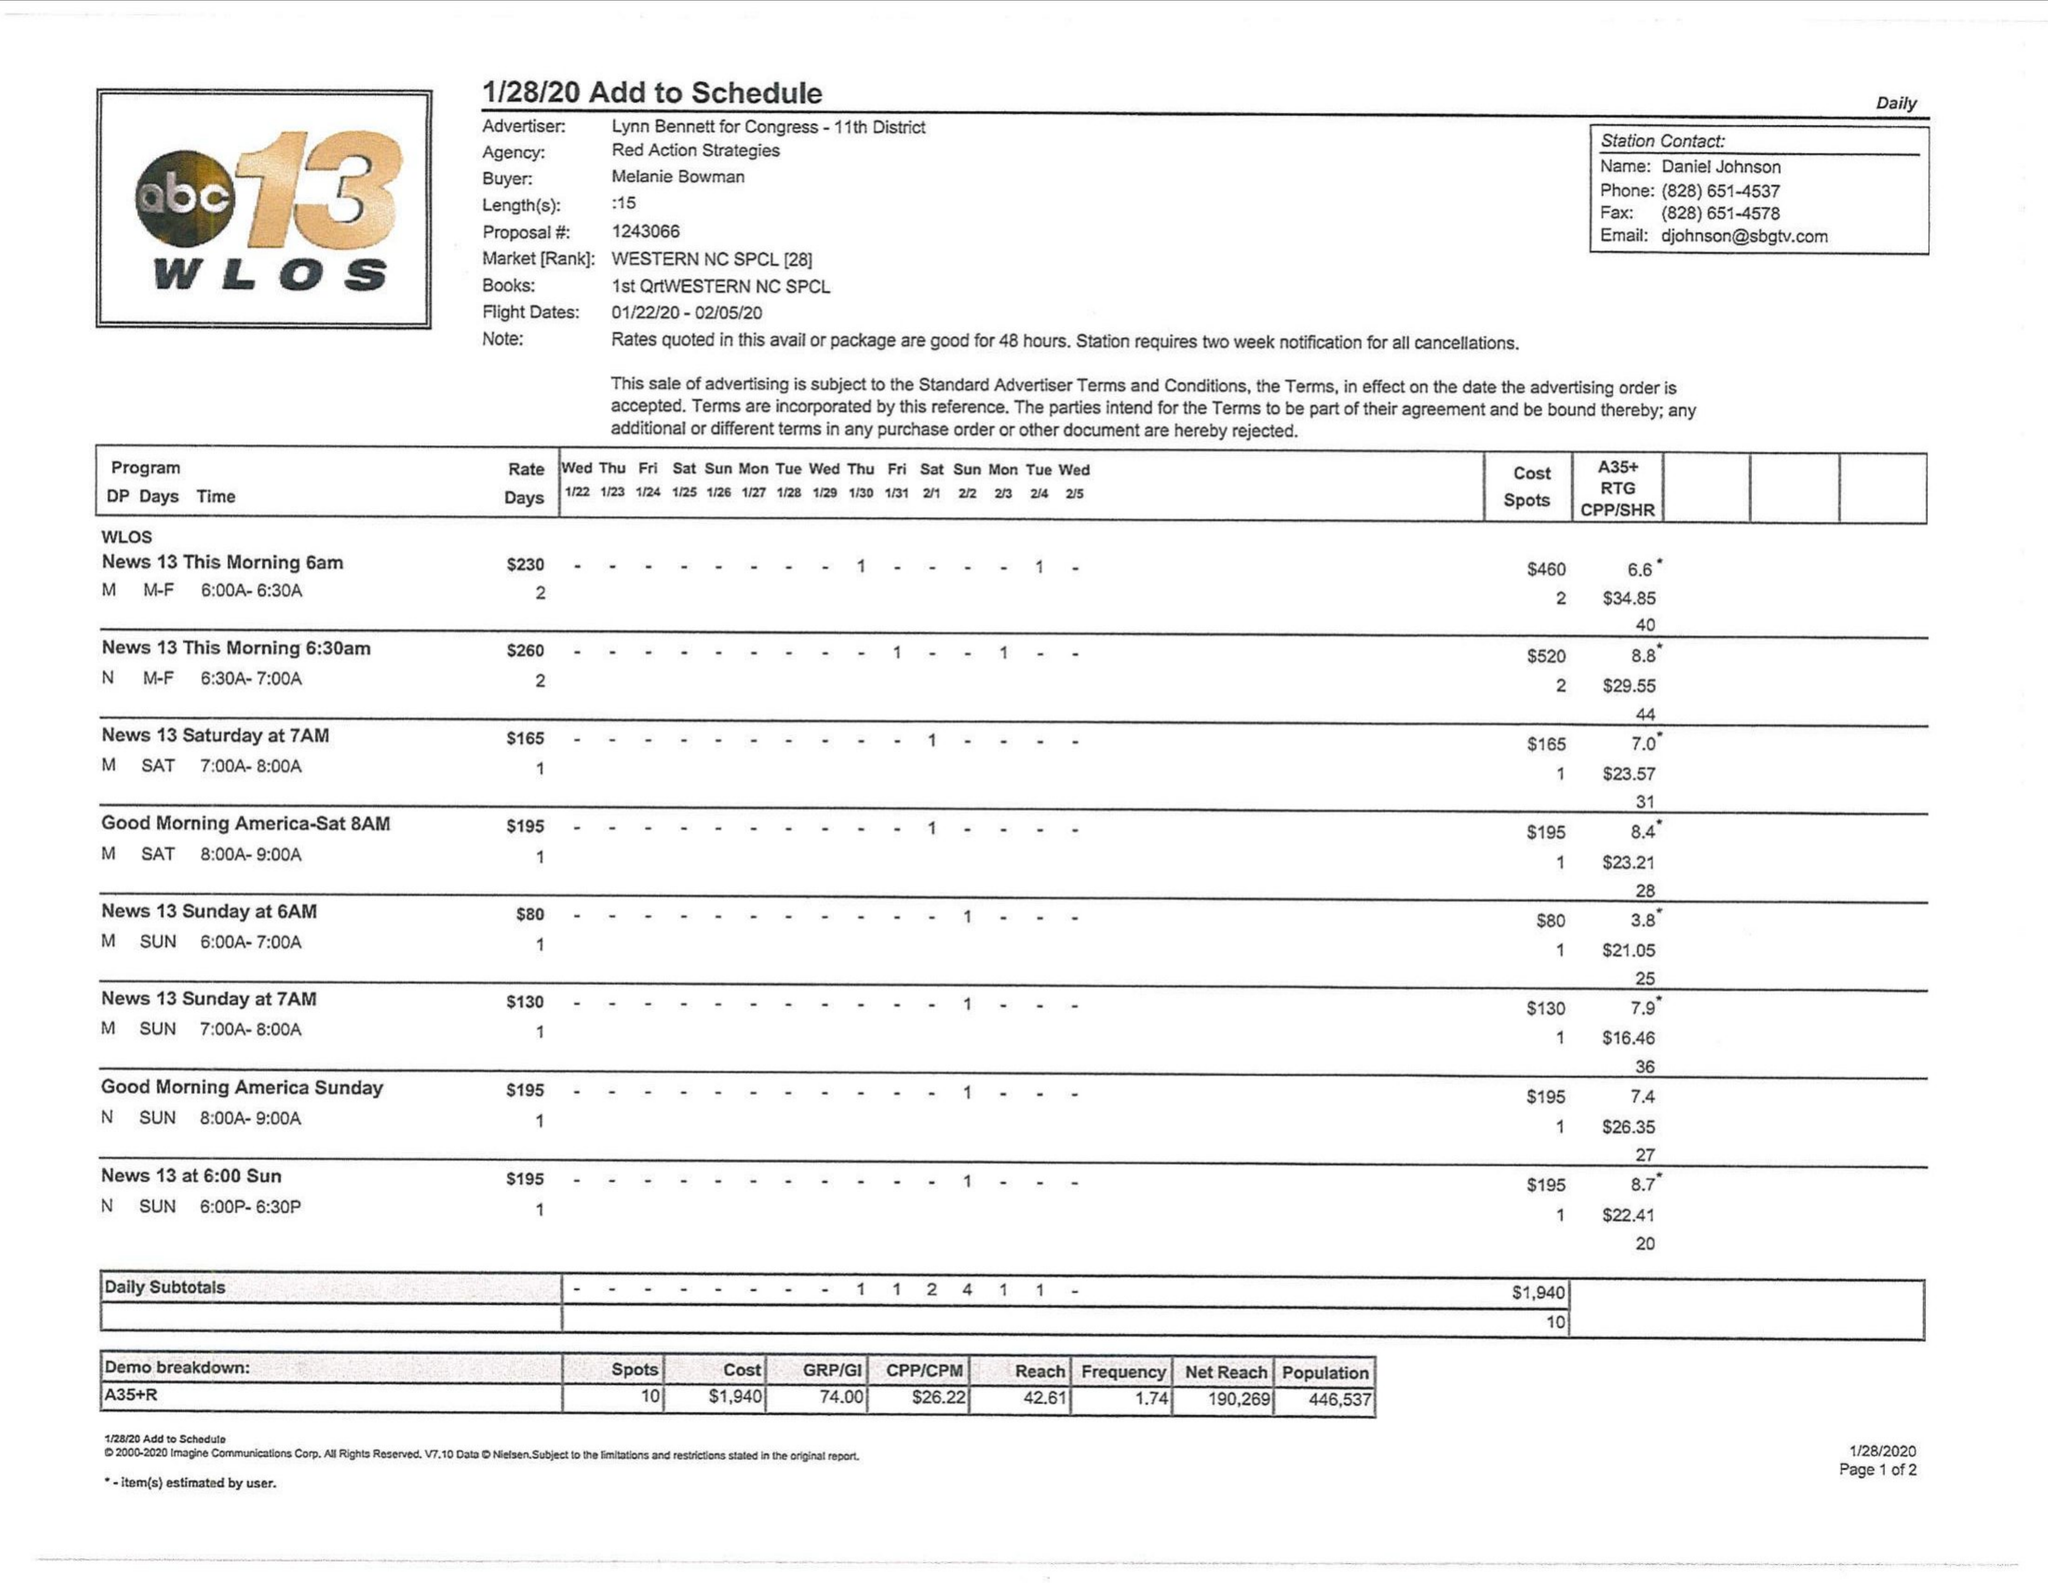What is the value for the advertiser?
Answer the question using a single word or phrase. LYNN BENNETT FOR CONGRESS- 11TH DISTRICT 